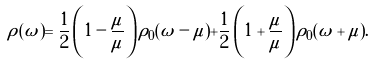<formula> <loc_0><loc_0><loc_500><loc_500>\rho ( \omega ) = \frac { 1 } { 2 } \left ( 1 - \frac { \mu } { \tilde { \mu } } \right ) \rho _ { 0 } ( \omega - \tilde { \mu } ) + \frac { 1 } { 2 } \left ( 1 + \frac { \mu } { \tilde { \mu } } \right ) \rho _ { 0 } ( \omega + \tilde { \mu } ) .</formula> 